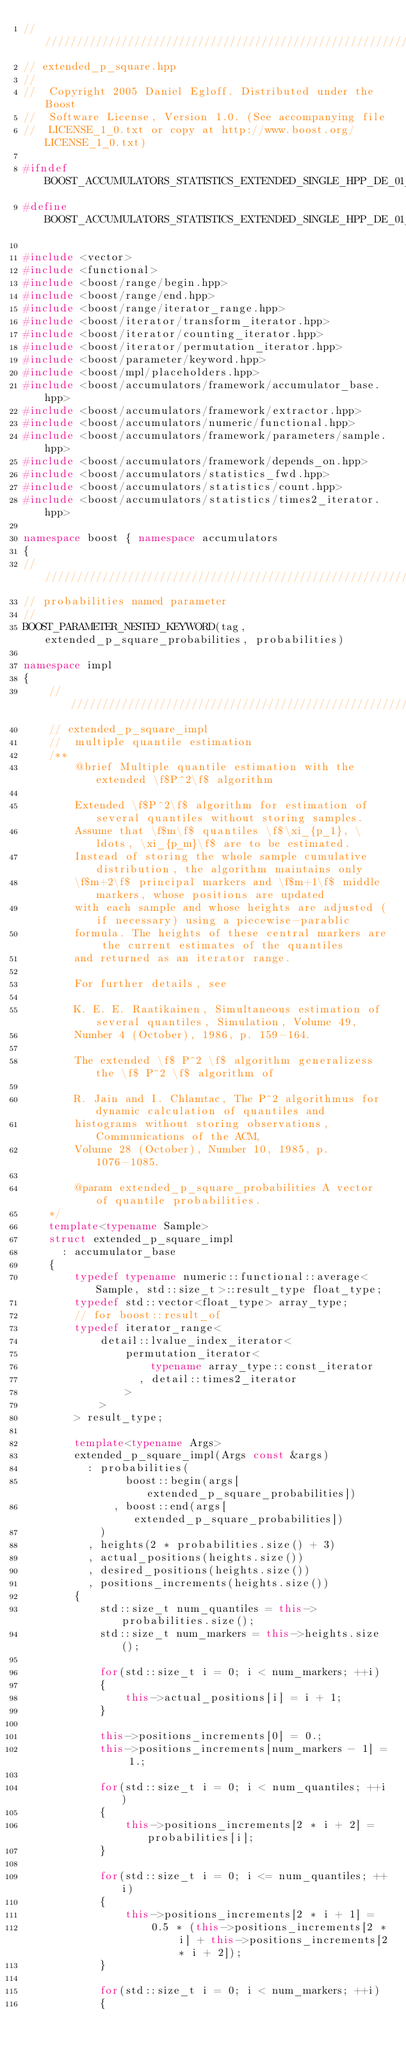Convert code to text. <code><loc_0><loc_0><loc_500><loc_500><_C++_>///////////////////////////////////////////////////////////////////////////////
// extended_p_square.hpp
//
//  Copyright 2005 Daniel Egloff. Distributed under the Boost
//  Software License, Version 1.0. (See accompanying file
//  LICENSE_1_0.txt or copy at http://www.boost.org/LICENSE_1_0.txt)

#ifndef BOOST_ACCUMULATORS_STATISTICS_EXTENDED_SINGLE_HPP_DE_01_01_2006
#define BOOST_ACCUMULATORS_STATISTICS_EXTENDED_SINGLE_HPP_DE_01_01_2006

#include <vector>
#include <functional>
#include <boost/range/begin.hpp>
#include <boost/range/end.hpp>
#include <boost/range/iterator_range.hpp>
#include <boost/iterator/transform_iterator.hpp>
#include <boost/iterator/counting_iterator.hpp>
#include <boost/iterator/permutation_iterator.hpp>
#include <boost/parameter/keyword.hpp>
#include <boost/mpl/placeholders.hpp>
#include <boost/accumulators/framework/accumulator_base.hpp>
#include <boost/accumulators/framework/extractor.hpp>
#include <boost/accumulators/numeric/functional.hpp>
#include <boost/accumulators/framework/parameters/sample.hpp>
#include <boost/accumulators/framework/depends_on.hpp>
#include <boost/accumulators/statistics_fwd.hpp>
#include <boost/accumulators/statistics/count.hpp>
#include <boost/accumulators/statistics/times2_iterator.hpp>

namespace boost { namespace accumulators
{
///////////////////////////////////////////////////////////////////////////////
// probabilities named parameter
//
BOOST_PARAMETER_NESTED_KEYWORD(tag, extended_p_square_probabilities, probabilities)

namespace impl
{
    ///////////////////////////////////////////////////////////////////////////////
    // extended_p_square_impl
    //  multiple quantile estimation
    /**
        @brief Multiple quantile estimation with the extended \f$P^2\f$ algorithm

        Extended \f$P^2\f$ algorithm for estimation of several quantiles without storing samples.
        Assume that \f$m\f$ quantiles \f$\xi_{p_1}, \ldots, \xi_{p_m}\f$ are to be estimated.
        Instead of storing the whole sample cumulative distribution, the algorithm maintains only
        \f$m+2\f$ principal markers and \f$m+1\f$ middle markers, whose positions are updated
        with each sample and whose heights are adjusted (if necessary) using a piecewise-parablic
        formula. The heights of these central markers are the current estimates of the quantiles
        and returned as an iterator range.

        For further details, see

        K. E. E. Raatikainen, Simultaneous estimation of several quantiles, Simulation, Volume 49,
        Number 4 (October), 1986, p. 159-164.

        The extended \f$ P^2 \f$ algorithm generalizess the \f$ P^2 \f$ algorithm of

        R. Jain and I. Chlamtac, The P^2 algorithmus for dynamic calculation of quantiles and
        histograms without storing observations, Communications of the ACM,
        Volume 28 (October), Number 10, 1985, p. 1076-1085.

        @param extended_p_square_probabilities A vector of quantile probabilities.
    */
    template<typename Sample>
    struct extended_p_square_impl
      : accumulator_base
    {
        typedef typename numeric::functional::average<Sample, std::size_t>::result_type float_type;
        typedef std::vector<float_type> array_type;
        // for boost::result_of
        typedef iterator_range<
            detail::lvalue_index_iterator<
                permutation_iterator<
                    typename array_type::const_iterator
                  , detail::times2_iterator
                >
            >
        > result_type;

        template<typename Args>
        extended_p_square_impl(Args const &args)
          : probabilities(
                boost::begin(args[extended_p_square_probabilities])
              , boost::end(args[extended_p_square_probabilities])
            )
          , heights(2 * probabilities.size() + 3)
          , actual_positions(heights.size())
          , desired_positions(heights.size())
          , positions_increments(heights.size())
        {
            std::size_t num_quantiles = this->probabilities.size();
            std::size_t num_markers = this->heights.size();

            for(std::size_t i = 0; i < num_markers; ++i)
            {
                this->actual_positions[i] = i + 1;
            }

            this->positions_increments[0] = 0.;
            this->positions_increments[num_markers - 1] = 1.;

            for(std::size_t i = 0; i < num_quantiles; ++i)
            {
                this->positions_increments[2 * i + 2] = probabilities[i];
            }

            for(std::size_t i = 0; i <= num_quantiles; ++i)
            {
                this->positions_increments[2 * i + 1] =
                    0.5 * (this->positions_increments[2 * i] + this->positions_increments[2 * i + 2]);
            }

            for(std::size_t i = 0; i < num_markers; ++i)
            {</code> 